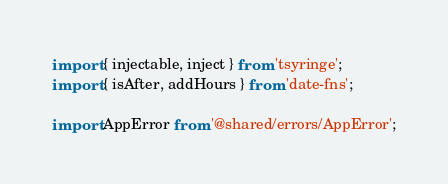Convert code to text. <code><loc_0><loc_0><loc_500><loc_500><_TypeScript_>import { injectable, inject } from 'tsyringe';
import { isAfter, addHours } from 'date-fns';

import AppError from '@shared/errors/AppError';</code> 